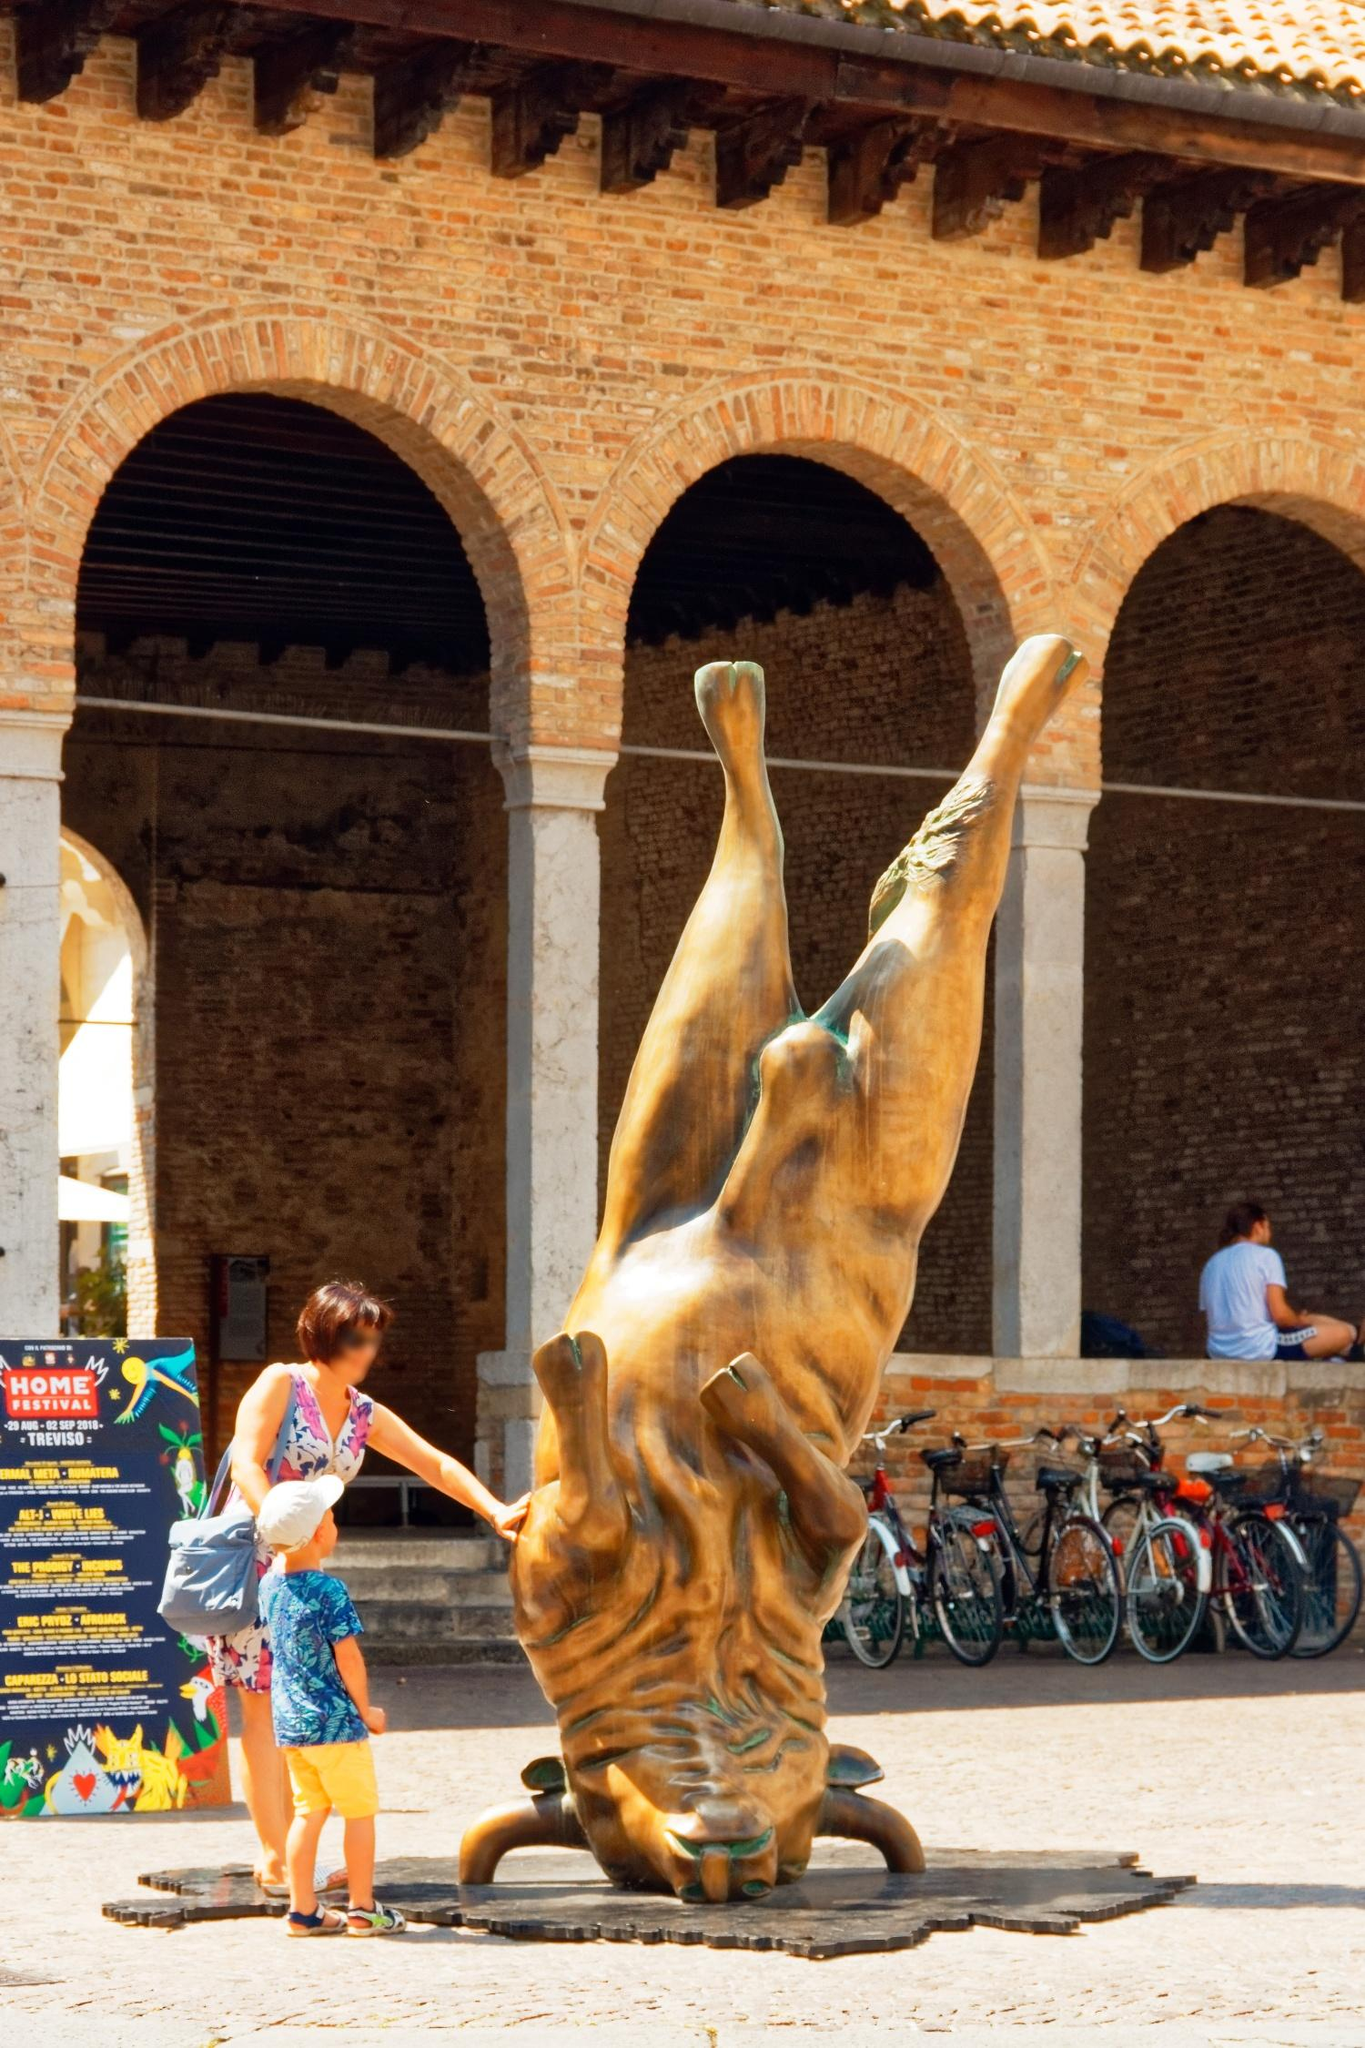Explain the visual content of the image in great detail. The image showcases a vivid scene within the courtyard of Castello Sforzesco in Milan, Italy. Dominating the center is a large, upside-down bronze sculpture of a bull, a piece of art that grabs immediate attention. The bull is intricately detailed, with its muscular features and bone structure accurately depicted, making viewers ponder the artist's intention behind displaying the sculpture in such a peculiar orientation.

Surrounding the sculpture are elements that blend the historical and the modern. The courtyard is encased by brick arches that harken back to the architecture of bygone eras, highlighting the castle's storied past. Modern bicycles are lined up against the walls, offering a stark juxtaposition to the historical ambiance and representing the active daily life of the city today.

A woman and a child stand close to the sculpture, interacting with it. The woman's hand reaches out to touch the bull, suggesting a tactile engagement with the art piece, while the child stands in awe, his curiosity piqued. This human element imbues the scene with a lively and relatable touch.

Towards the back of the courtyard, a young man sits casually on a ledge, absorbed in his own world, creating a sense of calm and leisure. Another detail is a vibrant sign promoting a 'HOME Festival' in Treviso, adding cultural and contemporary context to the scene, emphasizing the location's function as a hub for events and gatherings.

Overall, the image vividly captures a moment where art, history, and everyday life intersect seamlessly, providing a rich narrative without uttering a single word. 